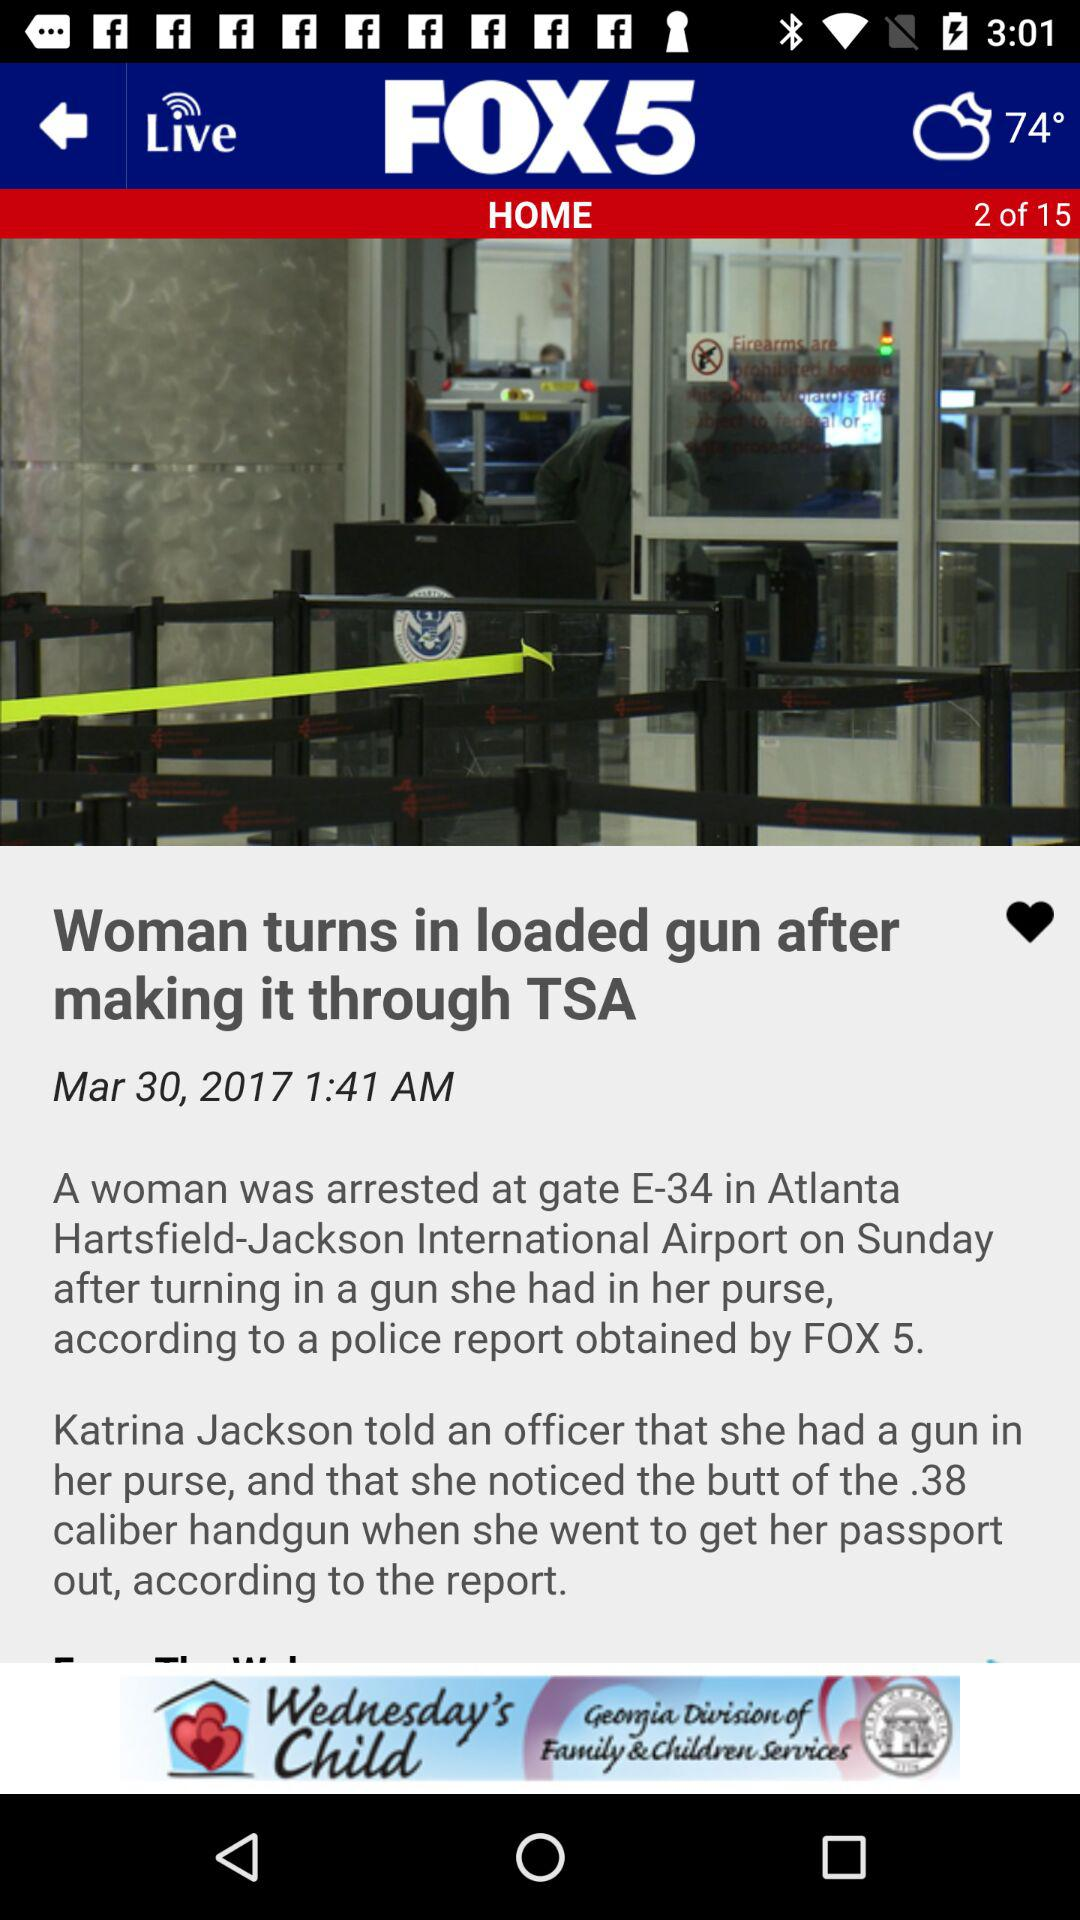How many pages are there? There are 15 pages. 